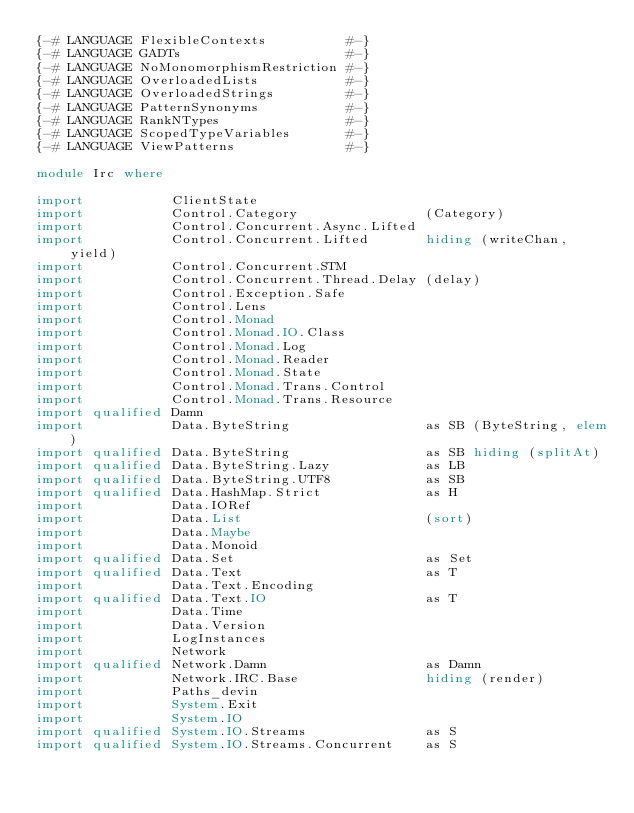Convert code to text. <code><loc_0><loc_0><loc_500><loc_500><_Haskell_>{-# LANGUAGE FlexibleContexts          #-}
{-# LANGUAGE GADTs                     #-}
{-# LANGUAGE NoMonomorphismRestriction #-}
{-# LANGUAGE OverloadedLists           #-}
{-# LANGUAGE OverloadedStrings         #-}
{-# LANGUAGE PatternSynonyms           #-}
{-# LANGUAGE RankNTypes                #-}
{-# LANGUAGE ScopedTypeVariables       #-}
{-# LANGUAGE ViewPatterns              #-}

module Irc where

import           ClientState
import           Control.Category                (Category)
import           Control.Concurrent.Async.Lifted
import           Control.Concurrent.Lifted       hiding (writeChan, yield)
import           Control.Concurrent.STM
import           Control.Concurrent.Thread.Delay (delay)
import           Control.Exception.Safe
import           Control.Lens
import           Control.Monad
import           Control.Monad.IO.Class
import           Control.Monad.Log
import           Control.Monad.Reader
import           Control.Monad.State
import           Control.Monad.Trans.Control
import           Control.Monad.Trans.Resource
import qualified Damn
import           Data.ByteString                 as SB (ByteString, elem)
import qualified Data.ByteString                 as SB hiding (splitAt)
import qualified Data.ByteString.Lazy            as LB
import qualified Data.ByteString.UTF8            as SB
import qualified Data.HashMap.Strict             as H
import           Data.IORef
import           Data.List                       (sort)
import           Data.Maybe
import           Data.Monoid
import qualified Data.Set                        as Set
import qualified Data.Text                       as T
import           Data.Text.Encoding
import qualified Data.Text.IO                    as T
import           Data.Time
import           Data.Version
import           LogInstances
import           Network
import qualified Network.Damn                    as Damn
import           Network.IRC.Base                hiding (render)
import           Paths_devin
import           System.Exit
import           System.IO
import qualified System.IO.Streams               as S
import qualified System.IO.Streams.Concurrent    as S</code> 